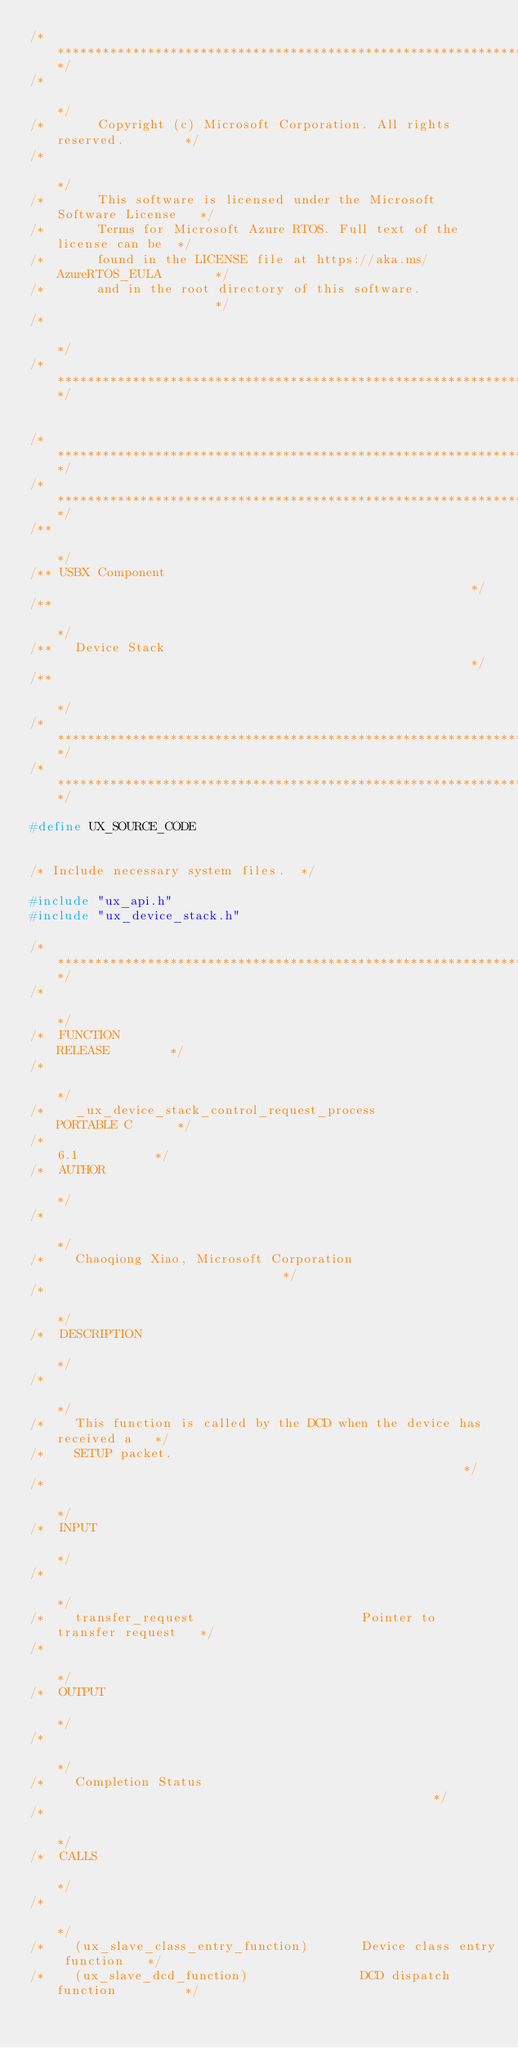<code> <loc_0><loc_0><loc_500><loc_500><_C_>/**************************************************************************/
/*                                                                        */
/*       Copyright (c) Microsoft Corporation. All rights reserved.        */
/*                                                                        */
/*       This software is licensed under the Microsoft Software License   */
/*       Terms for Microsoft Azure RTOS. Full text of the license can be  */
/*       found in the LICENSE file at https://aka.ms/AzureRTOS_EULA       */
/*       and in the root directory of this software.                      */
/*                                                                        */
/**************************************************************************/


/**************************************************************************/
/**************************************************************************/
/**                                                                       */ 
/** USBX Component                                                        */ 
/**                                                                       */
/**   Device Stack                                                        */
/**                                                                       */
/**************************************************************************/
/**************************************************************************/

#define UX_SOURCE_CODE


/* Include necessary system files.  */

#include "ux_api.h"
#include "ux_device_stack.h"

/**************************************************************************/
/*                                                                        */
/*  FUNCTION                                               RELEASE        */
/*                                                                        */
/*    _ux_device_stack_control_request_process            PORTABLE C      */
/*                                                           6.1          */
/*  AUTHOR                                                                */
/*                                                                        */
/*    Chaoqiong Xiao, Microsoft Corporation                               */
/*                                                                        */
/*  DESCRIPTION                                                           */
/*                                                                        */
/*    This function is called by the DCD when the device has received a   */
/*    SETUP packet.                                                       */
/*                                                                        */
/*  INPUT                                                                 */
/*                                                                        */
/*    transfer_request                      Pointer to transfer request   */
/*                                                                        */
/*  OUTPUT                                                                */
/*                                                                        */
/*    Completion Status                                                   */ 
/*                                                                        */
/*  CALLS                                                                 */ 
/*                                                                        */ 
/*    (ux_slave_class_entry_function)       Device class entry function   */ 
/*    (ux_slave_dcd_function)               DCD dispatch function         */ </code> 